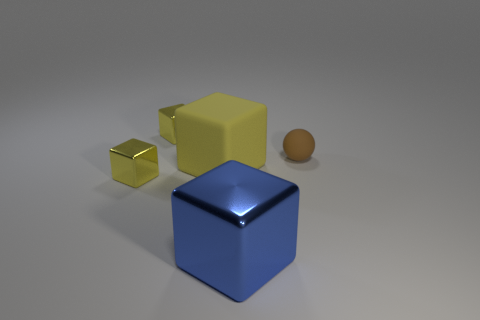How many yellow blocks must be subtracted to get 1 yellow blocks? 2 Subtract all yellow rubber blocks. How many blocks are left? 3 Subtract all yellow cylinders. How many yellow blocks are left? 3 Subtract all blue cubes. How many cubes are left? 3 Add 3 small brown things. How many objects exist? 8 Subtract all cubes. How many objects are left? 1 Add 2 yellow rubber cylinders. How many yellow rubber cylinders exist? 2 Subtract 0 blue balls. How many objects are left? 5 Subtract all cyan cubes. Subtract all purple cylinders. How many cubes are left? 4 Subtract all red shiny balls. Subtract all rubber blocks. How many objects are left? 4 